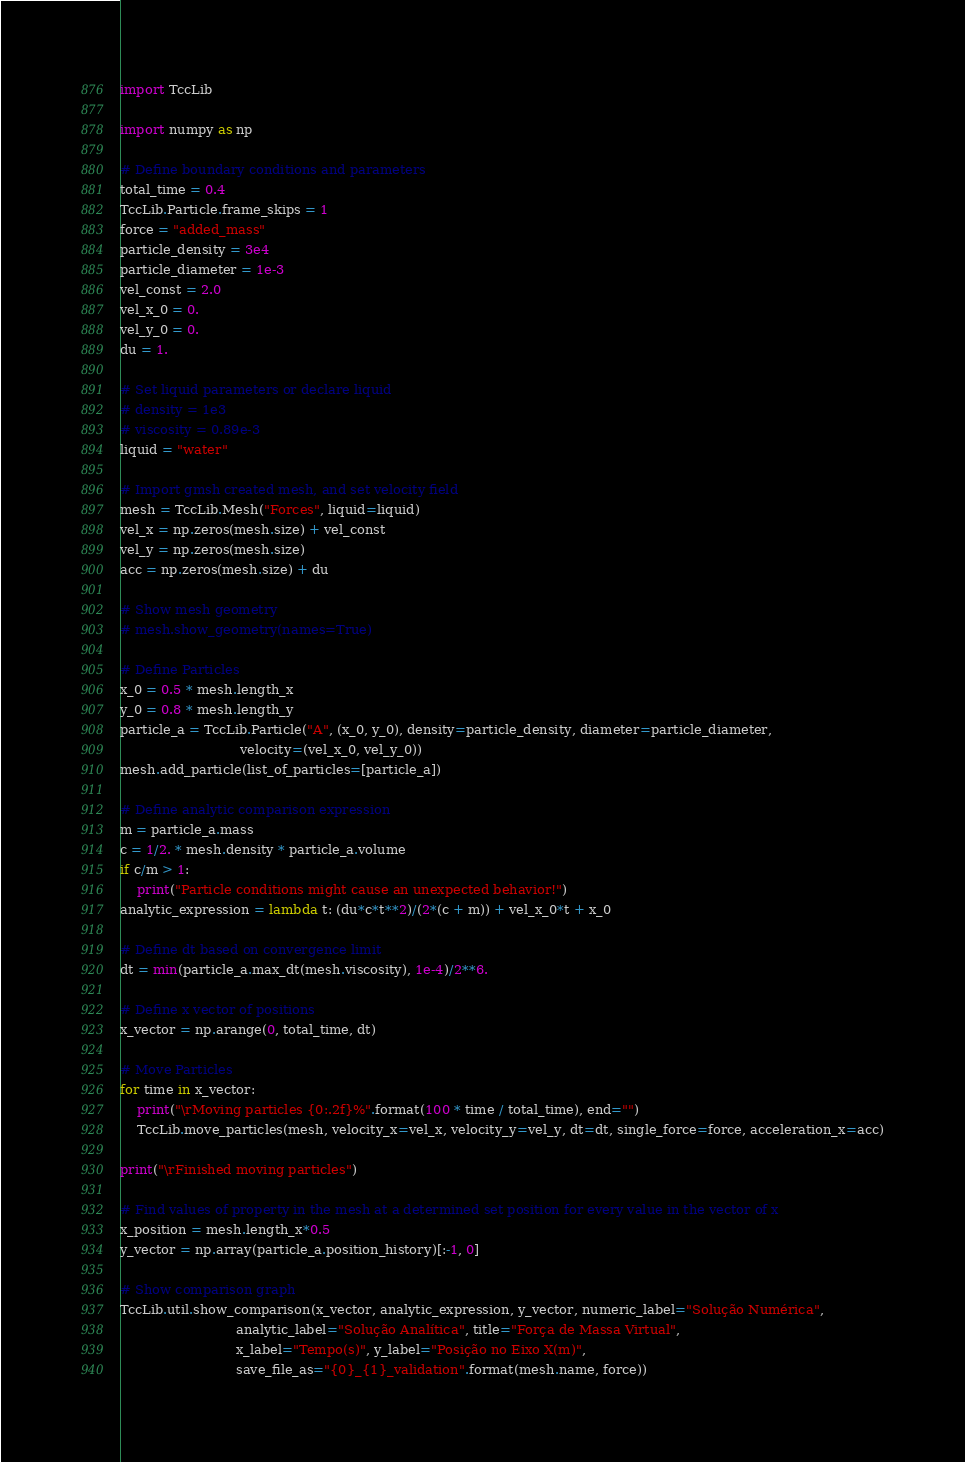Convert code to text. <code><loc_0><loc_0><loc_500><loc_500><_Python_>import TccLib

import numpy as np

# Define boundary conditions and parameters
total_time = 0.4
TccLib.Particle.frame_skips = 1
force = "added_mass"
particle_density = 3e4
particle_diameter = 1e-3
vel_const = 2.0
vel_x_0 = 0.
vel_y_0 = 0.
du = 1.

# Set liquid parameters or declare liquid
# density = 1e3
# viscosity = 0.89e-3
liquid = "water"

# Import gmsh created mesh, and set velocity field
mesh = TccLib.Mesh("Forces", liquid=liquid)
vel_x = np.zeros(mesh.size) + vel_const
vel_y = np.zeros(mesh.size)
acc = np.zeros(mesh.size) + du

# Show mesh geometry
# mesh.show_geometry(names=True)

# Define Particles
x_0 = 0.5 * mesh.length_x
y_0 = 0.8 * mesh.length_y
particle_a = TccLib.Particle("A", (x_0, y_0), density=particle_density, diameter=particle_diameter,
                             velocity=(vel_x_0, vel_y_0))
mesh.add_particle(list_of_particles=[particle_a])

# Define analytic comparison expression
m = particle_a.mass
c = 1/2. * mesh.density * particle_a.volume
if c/m > 1:
    print("Particle conditions might cause an unexpected behavior!")
analytic_expression = lambda t: (du*c*t**2)/(2*(c + m)) + vel_x_0*t + x_0

# Define dt based on convergence limit
dt = min(particle_a.max_dt(mesh.viscosity), 1e-4)/2**6.

# Define x vector of positions
x_vector = np.arange(0, total_time, dt)

# Move Particles
for time in x_vector:
    print("\rMoving particles {0:.2f}%".format(100 * time / total_time), end="")
    TccLib.move_particles(mesh, velocity_x=vel_x, velocity_y=vel_y, dt=dt, single_force=force, acceleration_x=acc)

print("\rFinished moving particles")

# Find values of property in the mesh at a determined set position for every value in the vector of x
x_position = mesh.length_x*0.5
y_vector = np.array(particle_a.position_history)[:-1, 0]

# Show comparison graph
TccLib.util.show_comparison(x_vector, analytic_expression, y_vector, numeric_label="Solução Numérica",
                            analytic_label="Solução Analítica", title="Força de Massa Virtual",
                            x_label="Tempo(s)", y_label="Posição no Eixo X(m)",
                            save_file_as="{0}_{1}_validation".format(mesh.name, force))
</code> 